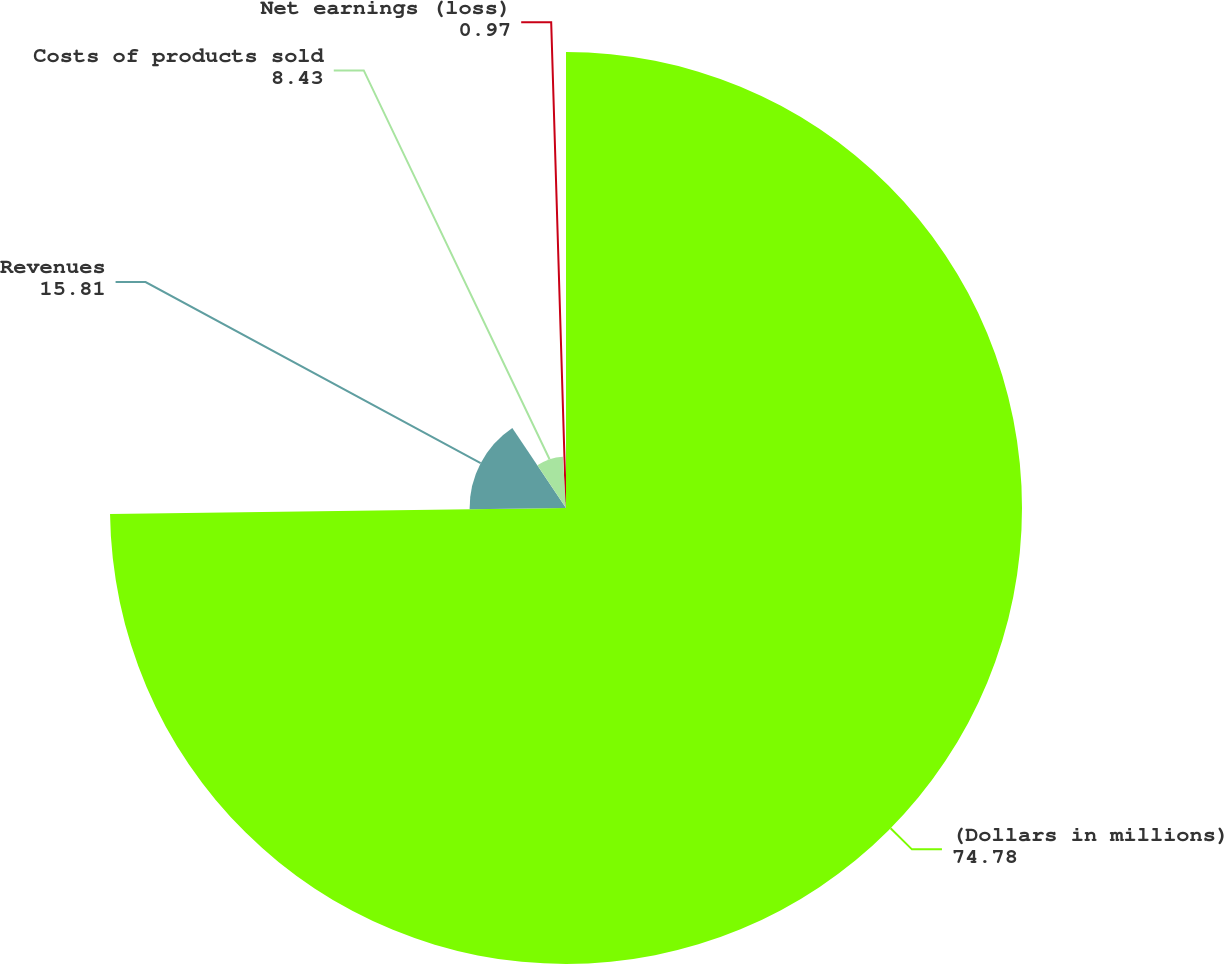<chart> <loc_0><loc_0><loc_500><loc_500><pie_chart><fcel>(Dollars in millions)<fcel>Revenues<fcel>Costs of products sold<fcel>Net earnings (loss)<nl><fcel>74.78%<fcel>15.81%<fcel>8.43%<fcel>0.97%<nl></chart> 